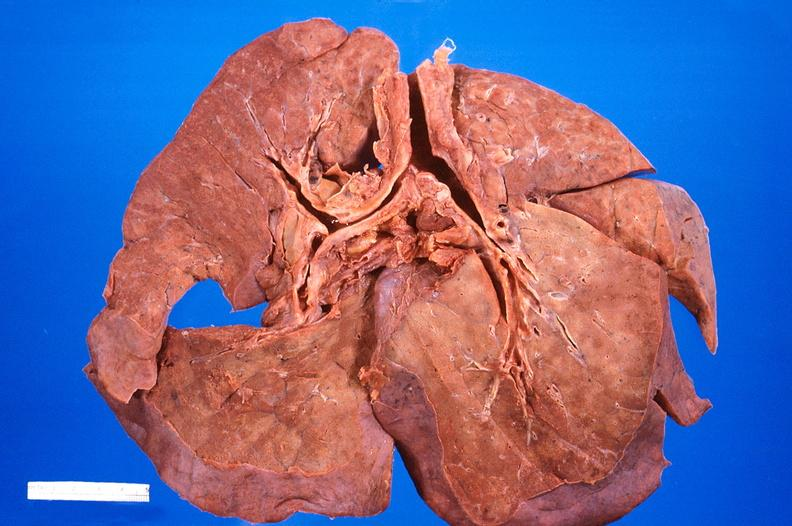does this image show lung, diffuse alveolar damage?
Answer the question using a single word or phrase. Yes 